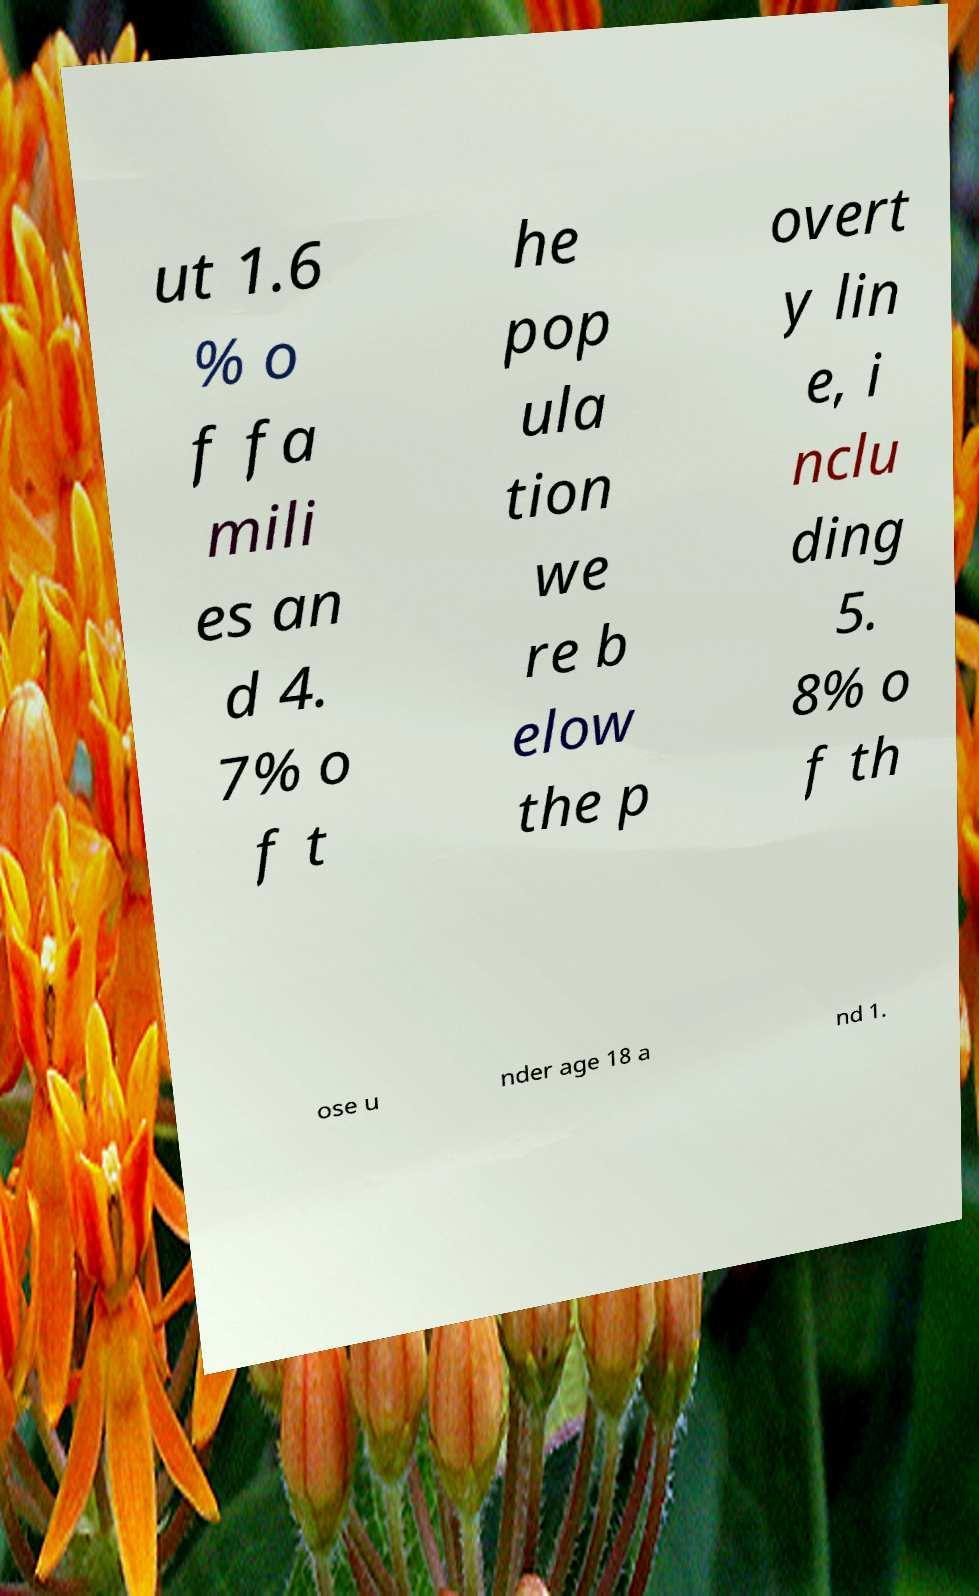What messages or text are displayed in this image? I need them in a readable, typed format. ut 1.6 % o f fa mili es an d 4. 7% o f t he pop ula tion we re b elow the p overt y lin e, i nclu ding 5. 8% o f th ose u nder age 18 a nd 1. 